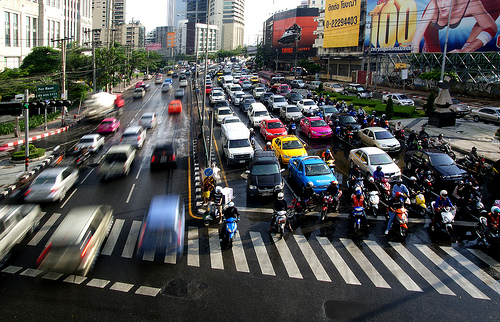<image>
Is the sky behind the car? Yes. From this viewpoint, the sky is positioned behind the car, with the car partially or fully occluding the sky. Is the car to the left of the car? Yes. From this viewpoint, the car is positioned to the left side relative to the car. 